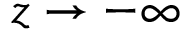Convert formula to latex. <formula><loc_0><loc_0><loc_500><loc_500>z \rightarrow { - \infty }</formula> 